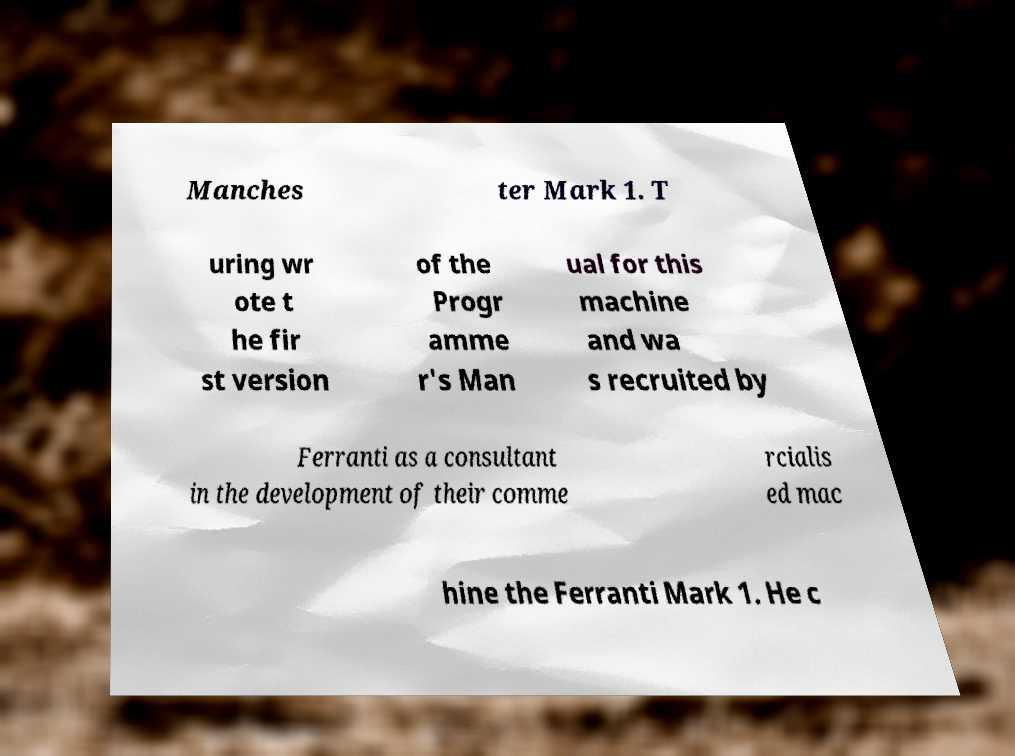Could you assist in decoding the text presented in this image and type it out clearly? Manches ter Mark 1. T uring wr ote t he fir st version of the Progr amme r's Man ual for this machine and wa s recruited by Ferranti as a consultant in the development of their comme rcialis ed mac hine the Ferranti Mark 1. He c 